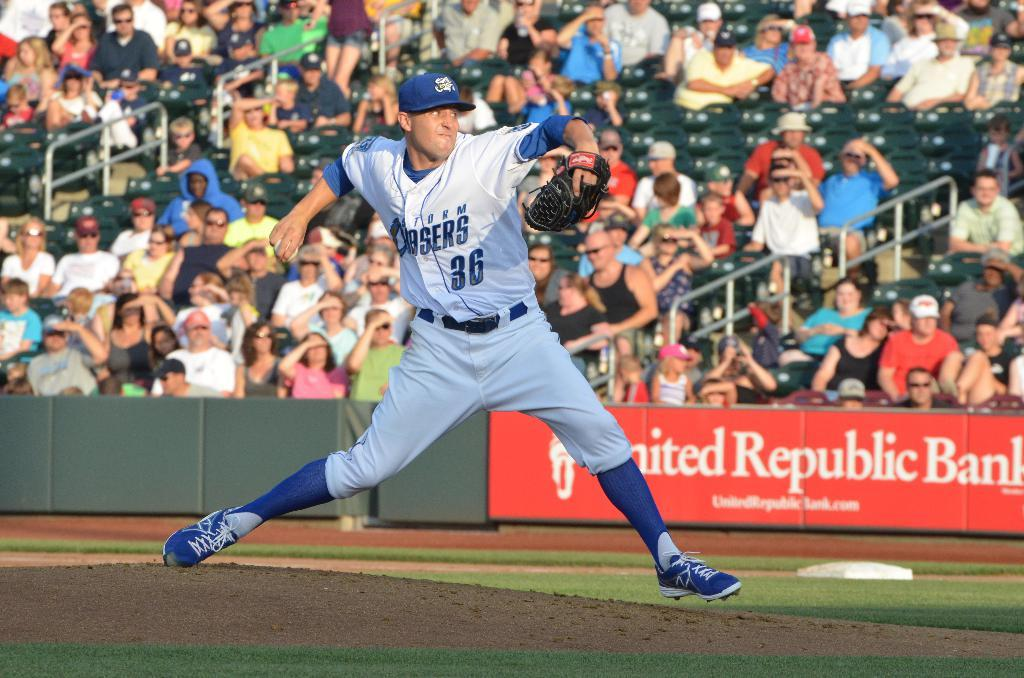Provide a one-sentence caption for the provided image. A baseball player in the field is wearing a storm chaser jersey. 